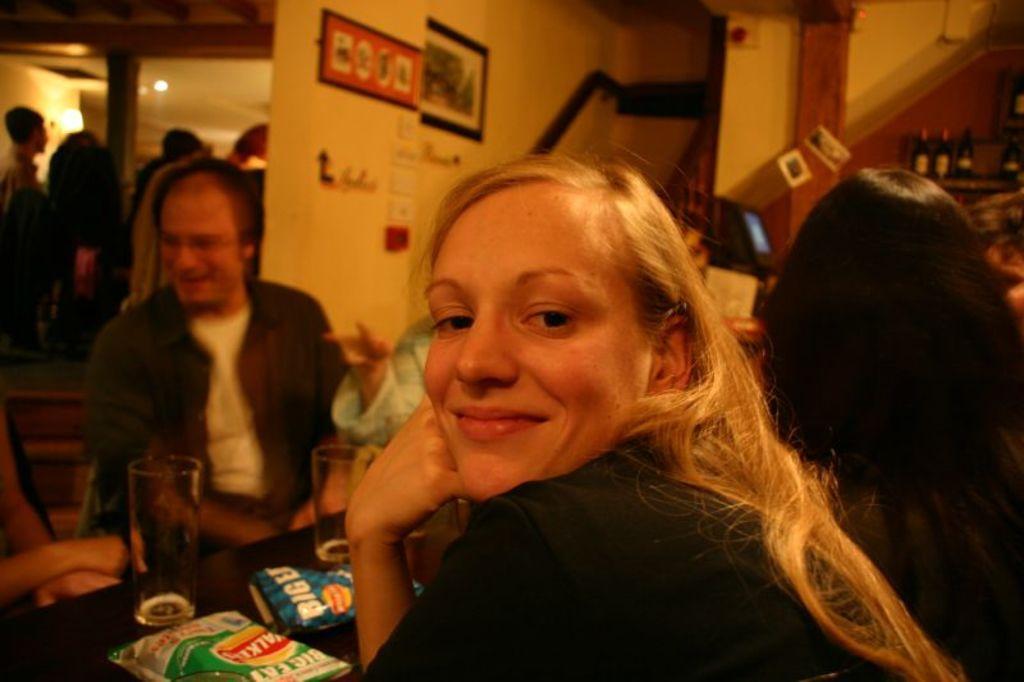Please provide a concise description of this image. In this Image I see a woman who is smiling and sitting and I can also see there is a table in front of her on which there are 2 glasses and 2 covers. In the background I see few people, will, a photo frame over here and I see the bottles over here. 